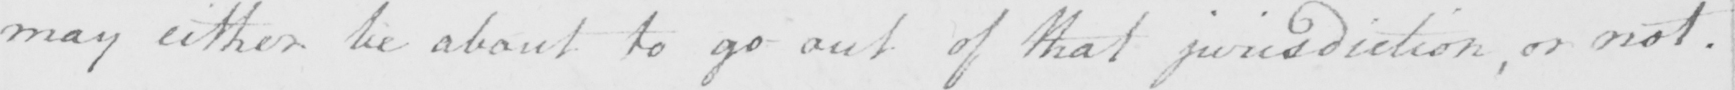Transcribe the text shown in this historical manuscript line. may either be about to go out of that jurisdiction , or not . 